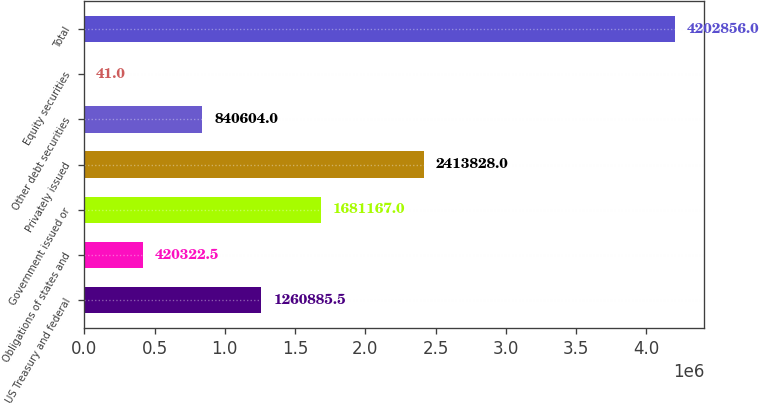Convert chart to OTSL. <chart><loc_0><loc_0><loc_500><loc_500><bar_chart><fcel>US Treasury and federal<fcel>Obligations of states and<fcel>Government issued or<fcel>Privately issued<fcel>Other debt securities<fcel>Equity securities<fcel>Total<nl><fcel>1.26089e+06<fcel>420322<fcel>1.68117e+06<fcel>2.41383e+06<fcel>840604<fcel>41<fcel>4.20286e+06<nl></chart> 